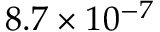<formula> <loc_0><loc_0><loc_500><loc_500>8 . 7 \times 1 0 ^ { - 7 }</formula> 